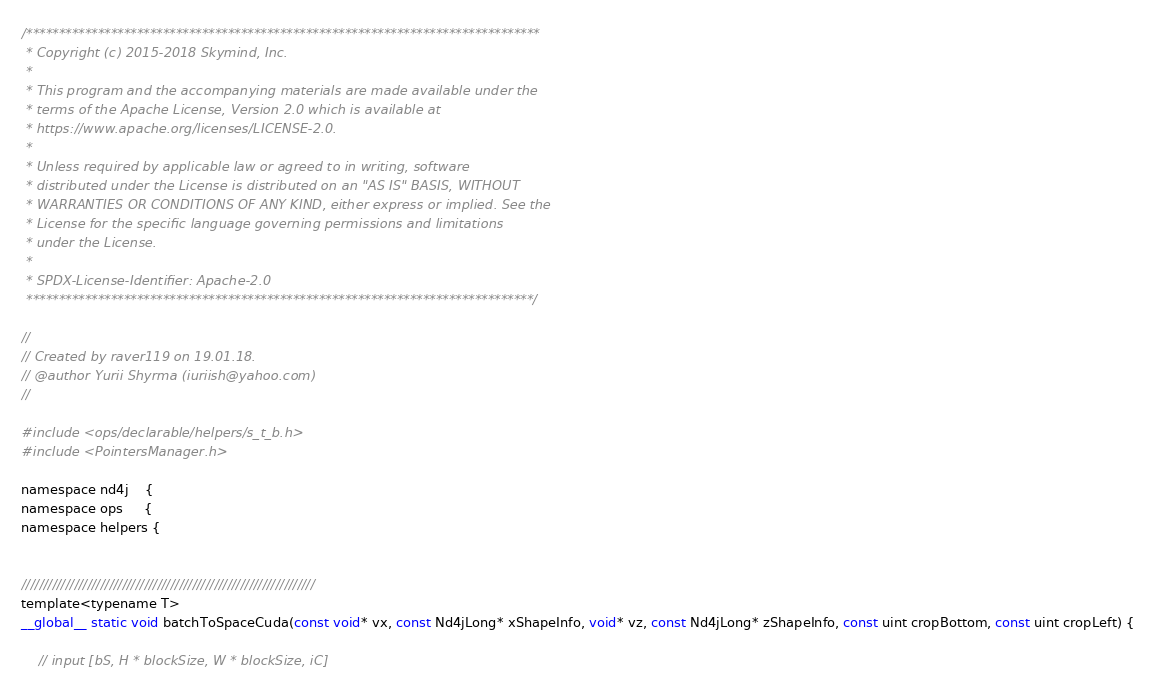<code> <loc_0><loc_0><loc_500><loc_500><_Cuda_>/*******************************************************************************
 * Copyright (c) 2015-2018 Skymind, Inc.
 *
 * This program and the accompanying materials are made available under the
 * terms of the Apache License, Version 2.0 which is available at
 * https://www.apache.org/licenses/LICENSE-2.0.
 *
 * Unless required by applicable law or agreed to in writing, software
 * distributed under the License is distributed on an "AS IS" BASIS, WITHOUT
 * WARRANTIES OR CONDITIONS OF ANY KIND, either express or implied. See the
 * License for the specific language governing permissions and limitations
 * under the License.
 *
 * SPDX-License-Identifier: Apache-2.0
 ******************************************************************************/

//
// Created by raver119 on 19.01.18.
// @author Yurii Shyrma (iuriish@yahoo.com)
//

#include <ops/declarable/helpers/s_t_b.h>
#include <PointersManager.h>

namespace nd4j    {
namespace ops     {
namespace helpers {


///////////////////////////////////////////////////////////////////
template<typename T>
__global__ static void batchToSpaceCuda(const void* vx, const Nd4jLong* xShapeInfo, void* vz, const Nd4jLong* zShapeInfo, const uint cropBottom, const uint cropLeft) {

    // input [bS, H * blockSize, W * blockSize, iC]</code> 